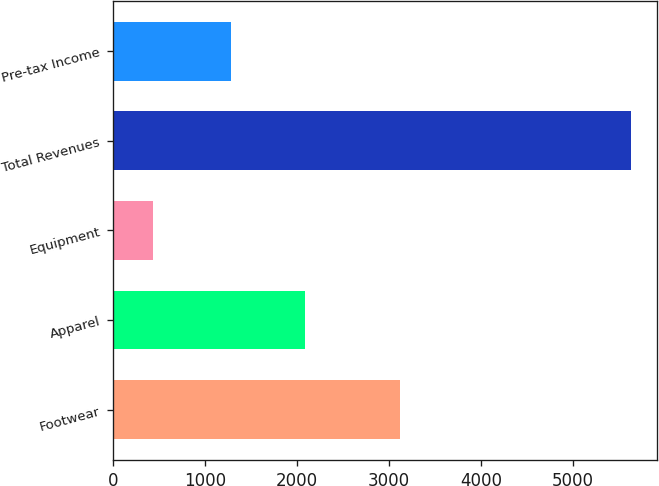<chart> <loc_0><loc_0><loc_500><loc_500><bar_chart><fcel>Footwear<fcel>Apparel<fcel>Equipment<fcel>Total Revenues<fcel>Pre-tax Income<nl><fcel>3112.6<fcel>2083.5<fcel>433.1<fcel>5629.2<fcel>1281.9<nl></chart> 